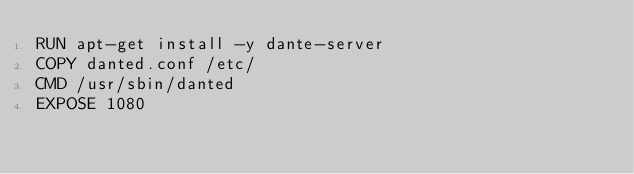Convert code to text. <code><loc_0><loc_0><loc_500><loc_500><_Dockerfile_>RUN apt-get install -y dante-server
COPY danted.conf /etc/
CMD /usr/sbin/danted
EXPOSE 1080
</code> 